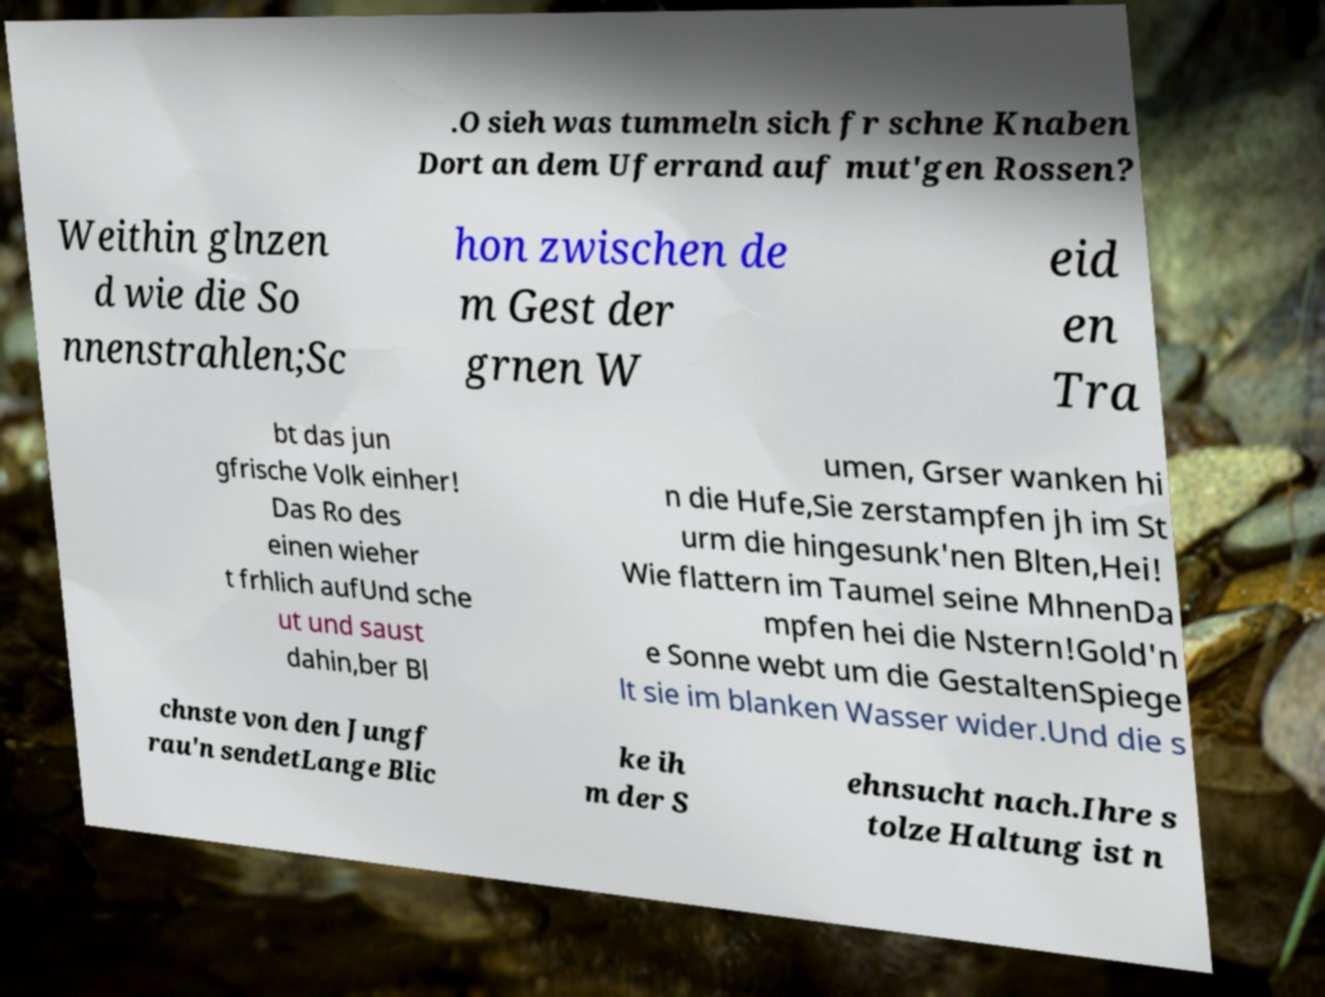For documentation purposes, I need the text within this image transcribed. Could you provide that? .O sieh was tummeln sich fr schne Knaben Dort an dem Uferrand auf mut'gen Rossen? Weithin glnzen d wie die So nnenstrahlen;Sc hon zwischen de m Gest der grnen W eid en Tra bt das jun gfrische Volk einher! Das Ro des einen wieher t frhlich aufUnd sche ut und saust dahin,ber Bl umen, Grser wanken hi n die Hufe,Sie zerstampfen jh im St urm die hingesunk'nen Blten,Hei! Wie flattern im Taumel seine MhnenDa mpfen hei die Nstern!Gold'n e Sonne webt um die GestaltenSpiege lt sie im blanken Wasser wider.Und die s chnste von den Jungf rau'n sendetLange Blic ke ih m der S ehnsucht nach.Ihre s tolze Haltung ist n 